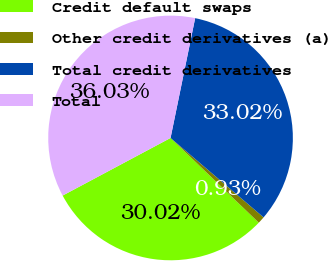Convert chart. <chart><loc_0><loc_0><loc_500><loc_500><pie_chart><fcel>Credit default swaps<fcel>Other credit derivatives (a)<fcel>Total credit derivatives<fcel>Total<nl><fcel>30.02%<fcel>0.93%<fcel>33.02%<fcel>36.03%<nl></chart> 